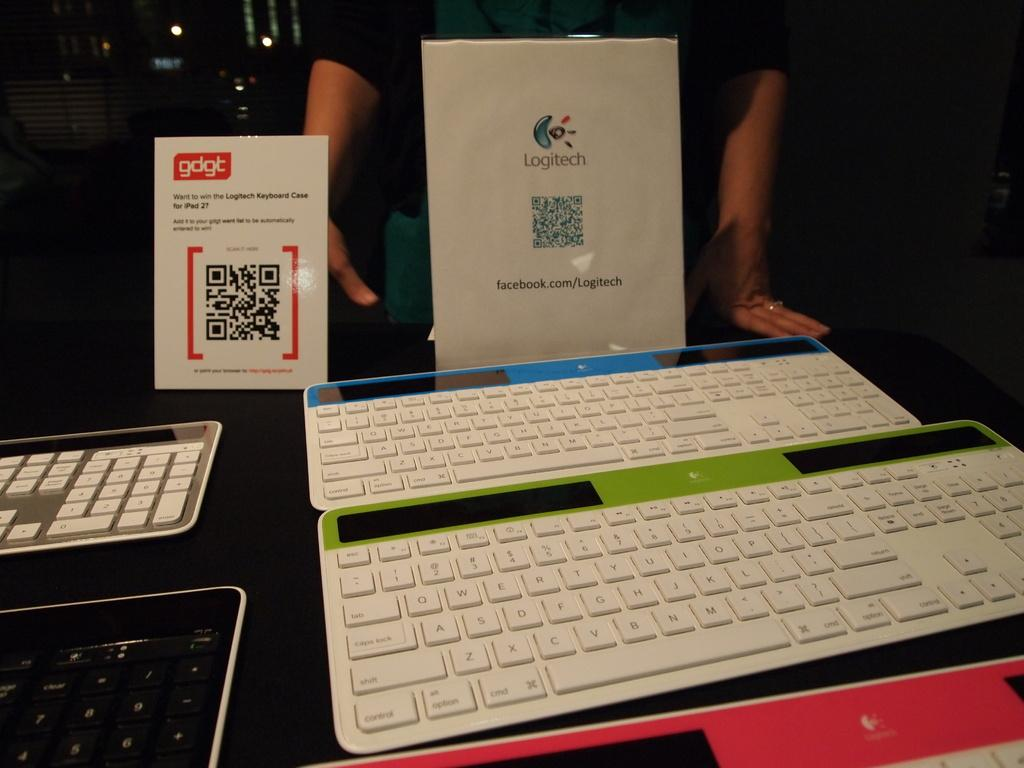<image>
Summarize the visual content of the image. Logitech sign in front of some Logitech keyboards. 